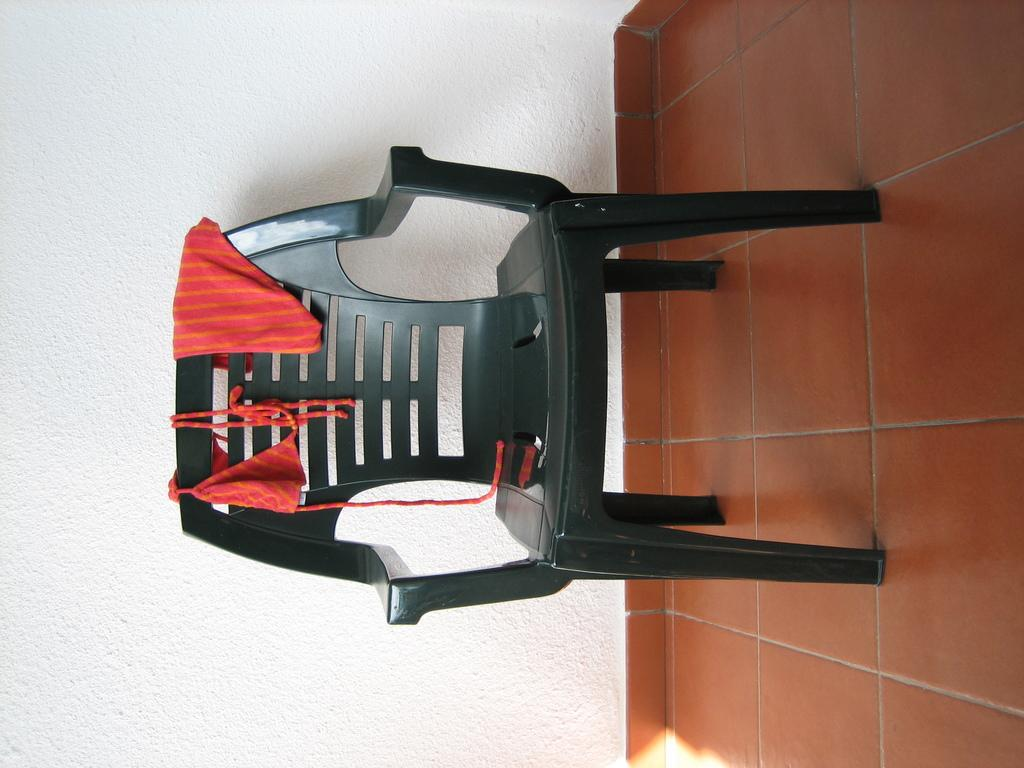What type of furniture is in the image? There is a chair in the image. What is the surface beneath the chair? The chair is on a tile surface. What is on top of the chair? There are winners on the chair. What can be seen behind the chair? There is a plain wall in the background of the image. What type of beam is holding up the ceiling in the image? There is no beam visible in the image; it only shows a chair, winners, and a plain wall. What type of destruction can be seen in the image? There is no destruction present in the image; it is a simple scene with a chair, winners, and a plain wall. 